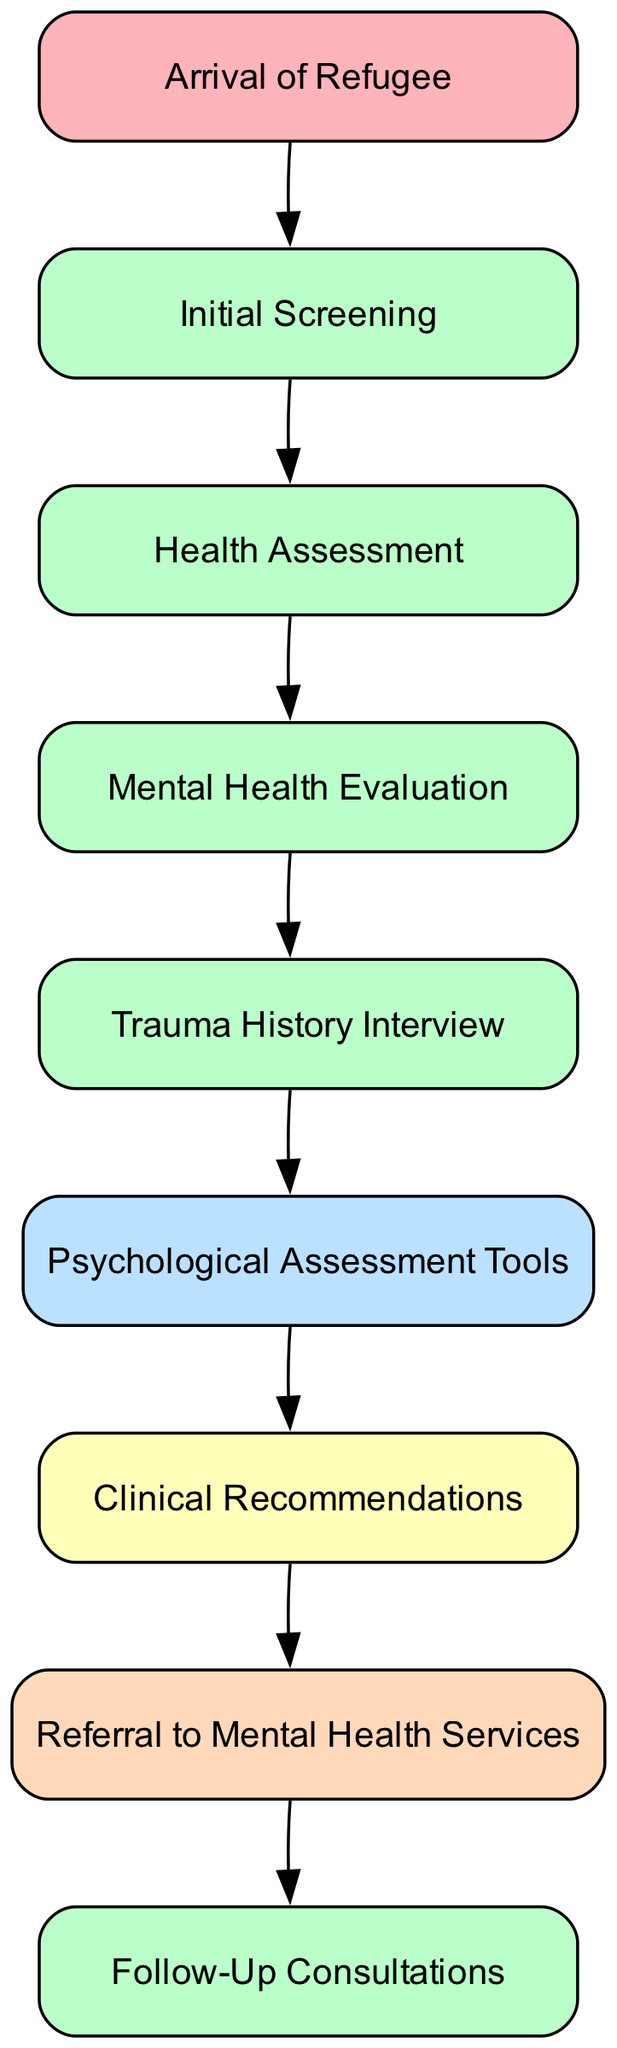What is the first step in the evaluation process? The first step in the evaluation process is the "Arrival of Refugee," indicating the initial point in the sequence where the refugee begins their journey through the evaluation.
Answer: Arrival of Refugee How many processes are involved in the evaluation? The diagram includes five processes: Initial Screening, Health Assessment, Mental Health Evaluation, Trauma History Interview, and Follow-Up Consultations.
Answer: 5 What is the last output of the diagram? The final output in the sequence is "Referral to Mental Health Services," representing the conclusion of the evaluation process with a direction for further action.
Answer: Referral to Mental Health Services Which element follows the "Mental Health Evaluation"? After the "Mental Health Evaluation," the next element is "Trauma History Interview," signifying the continuation of the evaluation with a specific focus on trauma history.
Answer: Trauma History Interview What type of element is "Psychological Assessment Tools"? "Psychological Assessment Tools" is categorized as a resource in the diagram, suggesting it provides support for the evaluation activities.
Answer: Resource In total, how many events are in the diagram? The diagram contains one event, which is the "Arrival of Refugee," marking a significant starting point in the evaluation process.
Answer: 1 Which process directly precedes the "Follow-Up Consultations"? The "Follow-Up Consultations" are directly preceded by "Clinical Recommendations," indicating the step where suggestions are made before follow-up actions.
Answer: Clinical Recommendations How are the elements connected in the sequence? The elements are connected in a linear flow, with each step leading directly to the next through directed edges, showcasing the structured path of the evaluation process.
Answer: Linear flow What action is represented at the end of the process? The action represented at the end of the process is "Referral to Mental Health Services," indicating a directed step following the evaluation.
Answer: Referral to Mental Health Services 